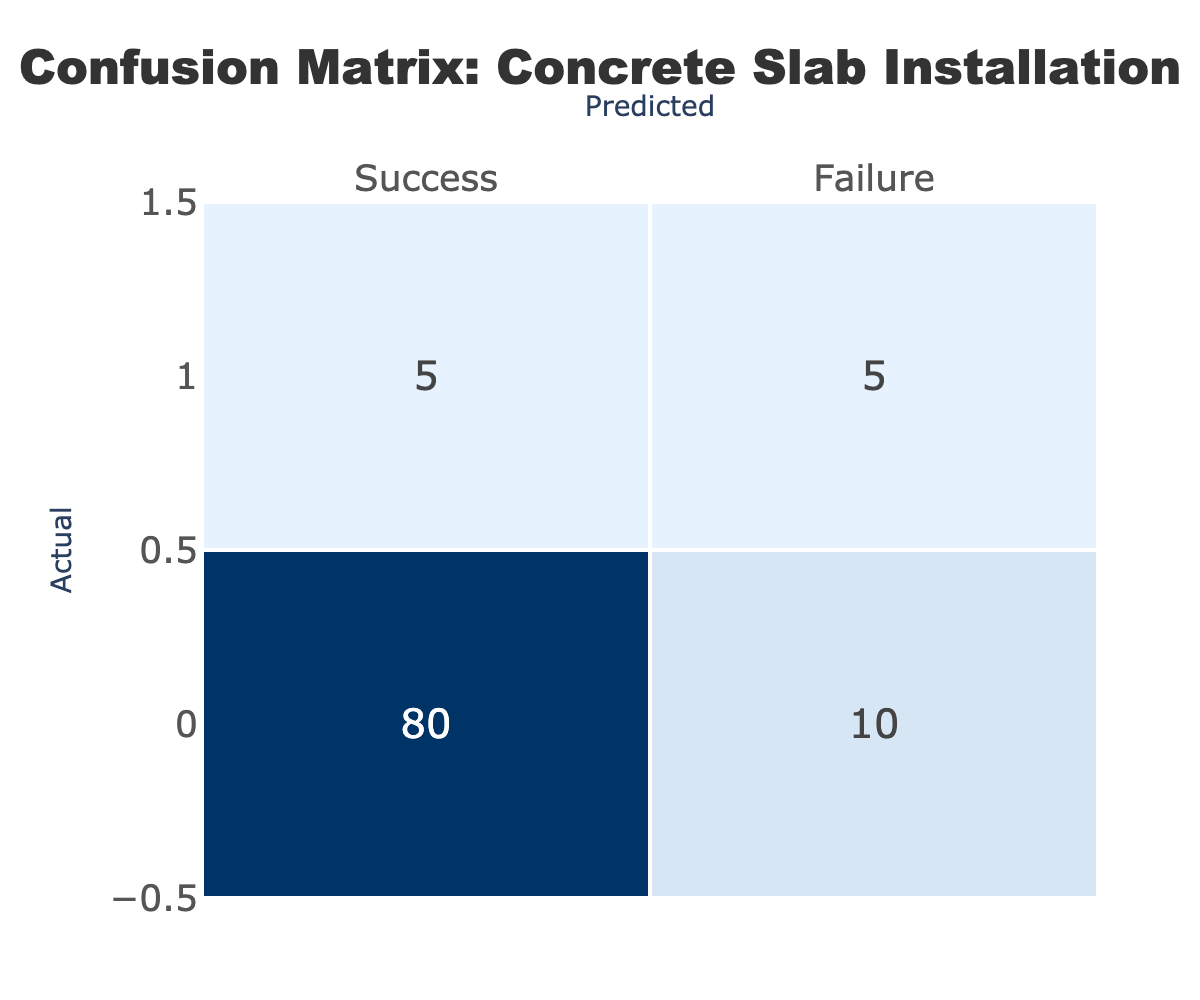What is the total number of successful installations? To find the total successful installations, we look at the value in the Success row under Actual, which is 80.
Answer: 80 What is the total number of failed installations? To find the total failed installations, we look at the value in the Failure row under Actual, which is 5.
Answer: 5 How many instances were incorrectly predicted as successful? The instances that were incorrectly predicted as successful can be found in the Failure row under Predicted, which is 5.
Answer: 5 What percentage of actual installations were successful? To calculate the percentage of successful installations, divide the total successful installations (80) by the total installations (80 + 5 + 10 + 5 = 100). Thus, (80 / 100) * 100 = 80%.
Answer: 80% Were there more successful installations than failures? Comparing the total actual successes (80) and failures (5), we see that 80 is greater than 5, confirming there were more successful installations.
Answer: Yes What is the total number of predictions made? The total predictions can be found by adding all values in the table: 80 (Success, Success) + 10 (Success, Failure) + 5 (Failure, Success) + 5 (Failure, Failure) = 100.
Answer: 100 How many successful installations were predicted as failures? The count of successful installations predicted as failures can be found in the Success row under Predicted, which is 10.
Answer: 10 What is the ratio of success to failure for the predicted outcomes? The success outcomes under Predicted is 80 and the failure outcomes is 10, hence the ratio is 80:10, which simplifies to 8:1.
Answer: 8:1 What is the overall accuracy of the predictions? The accuracy can be calculated by finding the sum of correct predictions (true successes + true failures) divided by total predictions: (80 + 5) / 100 = 85%.
Answer: 85% 